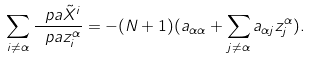Convert formula to latex. <formula><loc_0><loc_0><loc_500><loc_500>\sum _ { i \neq \alpha } \frac { \ p a \tilde { X } ^ { i } } { \ p a z _ { i } ^ { \alpha } } = - ( N + 1 ) ( a _ { \alpha \alpha } + \sum _ { j \neq \alpha } a _ { \alpha j } z _ { j } ^ { \alpha } ) .</formula> 